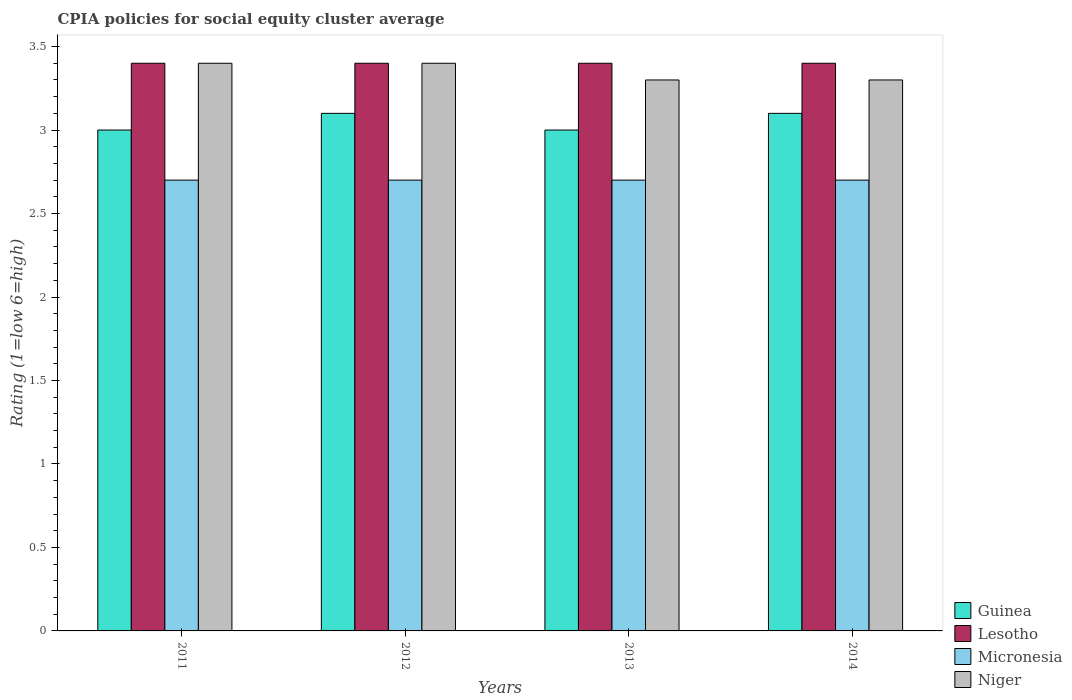How many different coloured bars are there?
Offer a terse response. 4. Are the number of bars per tick equal to the number of legend labels?
Make the answer very short. Yes. How many bars are there on the 1st tick from the left?
Offer a terse response. 4. What is the label of the 1st group of bars from the left?
Offer a very short reply. 2011. In how many cases, is the number of bars for a given year not equal to the number of legend labels?
Provide a succinct answer. 0. What is the CPIA rating in Guinea in 2011?
Offer a very short reply. 3. Across all years, what is the maximum CPIA rating in Guinea?
Your response must be concise. 3.1. Across all years, what is the minimum CPIA rating in Micronesia?
Your answer should be compact. 2.7. In which year was the CPIA rating in Micronesia maximum?
Make the answer very short. 2011. What is the total CPIA rating in Micronesia in the graph?
Your response must be concise. 10.8. What is the difference between the CPIA rating in Niger in 2011 and the CPIA rating in Micronesia in 2012?
Ensure brevity in your answer.  0.7. What is the average CPIA rating in Lesotho per year?
Give a very brief answer. 3.4. In the year 2012, what is the difference between the CPIA rating in Micronesia and CPIA rating in Niger?
Make the answer very short. -0.7. In how many years, is the CPIA rating in Micronesia greater than 2.3?
Provide a succinct answer. 4. What is the ratio of the CPIA rating in Micronesia in 2013 to that in 2014?
Make the answer very short. 1. Is the CPIA rating in Micronesia in 2011 less than that in 2012?
Offer a terse response. No. What is the difference between the highest and the second highest CPIA rating in Niger?
Offer a terse response. 0. What is the difference between the highest and the lowest CPIA rating in Guinea?
Offer a very short reply. 0.1. Is the sum of the CPIA rating in Guinea in 2012 and 2014 greater than the maximum CPIA rating in Micronesia across all years?
Make the answer very short. Yes. What does the 4th bar from the left in 2013 represents?
Provide a short and direct response. Niger. What does the 1st bar from the right in 2012 represents?
Offer a terse response. Niger. Is it the case that in every year, the sum of the CPIA rating in Micronesia and CPIA rating in Niger is greater than the CPIA rating in Guinea?
Make the answer very short. Yes. Are all the bars in the graph horizontal?
Provide a succinct answer. No. What is the difference between two consecutive major ticks on the Y-axis?
Provide a short and direct response. 0.5. Are the values on the major ticks of Y-axis written in scientific E-notation?
Ensure brevity in your answer.  No. Does the graph contain grids?
Your response must be concise. No. Where does the legend appear in the graph?
Give a very brief answer. Bottom right. How many legend labels are there?
Offer a terse response. 4. How are the legend labels stacked?
Ensure brevity in your answer.  Vertical. What is the title of the graph?
Make the answer very short. CPIA policies for social equity cluster average. What is the label or title of the Y-axis?
Your answer should be very brief. Rating (1=low 6=high). What is the Rating (1=low 6=high) of Guinea in 2011?
Offer a terse response. 3. What is the Rating (1=low 6=high) of Lesotho in 2011?
Make the answer very short. 3.4. What is the Rating (1=low 6=high) of Niger in 2011?
Your answer should be very brief. 3.4. What is the Rating (1=low 6=high) in Micronesia in 2012?
Keep it short and to the point. 2.7. What is the Rating (1=low 6=high) of Niger in 2012?
Offer a terse response. 3.4. What is the Rating (1=low 6=high) in Guinea in 2014?
Your answer should be compact. 3.1. What is the Rating (1=low 6=high) in Micronesia in 2014?
Provide a short and direct response. 2.7. What is the Rating (1=low 6=high) in Niger in 2014?
Offer a terse response. 3.3. Across all years, what is the maximum Rating (1=low 6=high) in Guinea?
Make the answer very short. 3.1. Across all years, what is the maximum Rating (1=low 6=high) in Micronesia?
Provide a succinct answer. 2.7. Across all years, what is the maximum Rating (1=low 6=high) in Niger?
Give a very brief answer. 3.4. Across all years, what is the minimum Rating (1=low 6=high) of Guinea?
Provide a succinct answer. 3. Across all years, what is the minimum Rating (1=low 6=high) in Lesotho?
Your answer should be compact. 3.4. Across all years, what is the minimum Rating (1=low 6=high) in Micronesia?
Give a very brief answer. 2.7. What is the total Rating (1=low 6=high) of Lesotho in the graph?
Your answer should be very brief. 13.6. What is the total Rating (1=low 6=high) in Micronesia in the graph?
Your answer should be very brief. 10.8. What is the total Rating (1=low 6=high) of Niger in the graph?
Your answer should be compact. 13.4. What is the difference between the Rating (1=low 6=high) of Guinea in 2011 and that in 2012?
Offer a terse response. -0.1. What is the difference between the Rating (1=low 6=high) of Lesotho in 2011 and that in 2012?
Your answer should be very brief. 0. What is the difference between the Rating (1=low 6=high) of Micronesia in 2011 and that in 2012?
Your answer should be very brief. 0. What is the difference between the Rating (1=low 6=high) in Niger in 2011 and that in 2012?
Your answer should be very brief. 0. What is the difference between the Rating (1=low 6=high) in Micronesia in 2011 and that in 2013?
Ensure brevity in your answer.  0. What is the difference between the Rating (1=low 6=high) of Niger in 2011 and that in 2013?
Offer a very short reply. 0.1. What is the difference between the Rating (1=low 6=high) in Guinea in 2011 and that in 2014?
Keep it short and to the point. -0.1. What is the difference between the Rating (1=low 6=high) in Lesotho in 2011 and that in 2014?
Your answer should be compact. 0. What is the difference between the Rating (1=low 6=high) in Micronesia in 2011 and that in 2014?
Provide a succinct answer. 0. What is the difference between the Rating (1=low 6=high) in Lesotho in 2012 and that in 2013?
Ensure brevity in your answer.  0. What is the difference between the Rating (1=low 6=high) in Micronesia in 2012 and that in 2013?
Make the answer very short. 0. What is the difference between the Rating (1=low 6=high) of Guinea in 2012 and that in 2014?
Ensure brevity in your answer.  0. What is the difference between the Rating (1=low 6=high) in Lesotho in 2012 and that in 2014?
Ensure brevity in your answer.  0. What is the difference between the Rating (1=low 6=high) of Niger in 2012 and that in 2014?
Offer a very short reply. 0.1. What is the difference between the Rating (1=low 6=high) in Micronesia in 2013 and that in 2014?
Make the answer very short. 0. What is the difference between the Rating (1=low 6=high) of Guinea in 2011 and the Rating (1=low 6=high) of Lesotho in 2012?
Give a very brief answer. -0.4. What is the difference between the Rating (1=low 6=high) in Guinea in 2011 and the Rating (1=low 6=high) in Micronesia in 2012?
Provide a succinct answer. 0.3. What is the difference between the Rating (1=low 6=high) in Guinea in 2011 and the Rating (1=low 6=high) in Micronesia in 2014?
Keep it short and to the point. 0.3. What is the difference between the Rating (1=low 6=high) in Lesotho in 2011 and the Rating (1=low 6=high) in Niger in 2014?
Offer a very short reply. 0.1. What is the difference between the Rating (1=low 6=high) in Guinea in 2012 and the Rating (1=low 6=high) in Niger in 2013?
Give a very brief answer. -0.2. What is the difference between the Rating (1=low 6=high) of Lesotho in 2012 and the Rating (1=low 6=high) of Micronesia in 2013?
Your answer should be compact. 0.7. What is the difference between the Rating (1=low 6=high) of Lesotho in 2012 and the Rating (1=low 6=high) of Niger in 2013?
Offer a very short reply. 0.1. What is the difference between the Rating (1=low 6=high) in Micronesia in 2012 and the Rating (1=low 6=high) in Niger in 2013?
Provide a short and direct response. -0.6. What is the difference between the Rating (1=low 6=high) of Guinea in 2012 and the Rating (1=low 6=high) of Lesotho in 2014?
Make the answer very short. -0.3. What is the difference between the Rating (1=low 6=high) in Guinea in 2012 and the Rating (1=low 6=high) in Micronesia in 2014?
Ensure brevity in your answer.  0.4. What is the difference between the Rating (1=low 6=high) of Lesotho in 2012 and the Rating (1=low 6=high) of Niger in 2014?
Provide a short and direct response. 0.1. What is the difference between the Rating (1=low 6=high) of Micronesia in 2012 and the Rating (1=low 6=high) of Niger in 2014?
Make the answer very short. -0.6. What is the difference between the Rating (1=low 6=high) of Guinea in 2013 and the Rating (1=low 6=high) of Niger in 2014?
Your response must be concise. -0.3. What is the average Rating (1=low 6=high) in Guinea per year?
Offer a very short reply. 3.05. What is the average Rating (1=low 6=high) of Micronesia per year?
Provide a succinct answer. 2.7. What is the average Rating (1=low 6=high) of Niger per year?
Your answer should be compact. 3.35. In the year 2011, what is the difference between the Rating (1=low 6=high) of Guinea and Rating (1=low 6=high) of Lesotho?
Give a very brief answer. -0.4. In the year 2011, what is the difference between the Rating (1=low 6=high) in Guinea and Rating (1=low 6=high) in Micronesia?
Your answer should be compact. 0.3. In the year 2011, what is the difference between the Rating (1=low 6=high) in Guinea and Rating (1=low 6=high) in Niger?
Provide a succinct answer. -0.4. In the year 2011, what is the difference between the Rating (1=low 6=high) in Lesotho and Rating (1=low 6=high) in Micronesia?
Make the answer very short. 0.7. In the year 2011, what is the difference between the Rating (1=low 6=high) in Micronesia and Rating (1=low 6=high) in Niger?
Your response must be concise. -0.7. In the year 2012, what is the difference between the Rating (1=low 6=high) in Guinea and Rating (1=low 6=high) in Lesotho?
Offer a terse response. -0.3. In the year 2012, what is the difference between the Rating (1=low 6=high) in Guinea and Rating (1=low 6=high) in Niger?
Keep it short and to the point. -0.3. In the year 2012, what is the difference between the Rating (1=low 6=high) of Lesotho and Rating (1=low 6=high) of Micronesia?
Offer a very short reply. 0.7. In the year 2012, what is the difference between the Rating (1=low 6=high) of Lesotho and Rating (1=low 6=high) of Niger?
Your response must be concise. 0. In the year 2012, what is the difference between the Rating (1=low 6=high) of Micronesia and Rating (1=low 6=high) of Niger?
Offer a very short reply. -0.7. In the year 2013, what is the difference between the Rating (1=low 6=high) in Guinea and Rating (1=low 6=high) in Lesotho?
Keep it short and to the point. -0.4. In the year 2013, what is the difference between the Rating (1=low 6=high) of Guinea and Rating (1=low 6=high) of Micronesia?
Ensure brevity in your answer.  0.3. In the year 2013, what is the difference between the Rating (1=low 6=high) of Lesotho and Rating (1=low 6=high) of Niger?
Your response must be concise. 0.1. In the year 2013, what is the difference between the Rating (1=low 6=high) in Micronesia and Rating (1=low 6=high) in Niger?
Provide a short and direct response. -0.6. In the year 2014, what is the difference between the Rating (1=low 6=high) in Guinea and Rating (1=low 6=high) in Micronesia?
Offer a terse response. 0.4. In the year 2014, what is the difference between the Rating (1=low 6=high) of Lesotho and Rating (1=low 6=high) of Micronesia?
Make the answer very short. 0.7. In the year 2014, what is the difference between the Rating (1=low 6=high) of Lesotho and Rating (1=low 6=high) of Niger?
Give a very brief answer. 0.1. What is the ratio of the Rating (1=low 6=high) of Guinea in 2011 to that in 2012?
Keep it short and to the point. 0.97. What is the ratio of the Rating (1=low 6=high) of Micronesia in 2011 to that in 2012?
Offer a very short reply. 1. What is the ratio of the Rating (1=low 6=high) in Guinea in 2011 to that in 2013?
Offer a terse response. 1. What is the ratio of the Rating (1=low 6=high) of Lesotho in 2011 to that in 2013?
Give a very brief answer. 1. What is the ratio of the Rating (1=low 6=high) in Niger in 2011 to that in 2013?
Offer a terse response. 1.03. What is the ratio of the Rating (1=low 6=high) of Micronesia in 2011 to that in 2014?
Your answer should be compact. 1. What is the ratio of the Rating (1=low 6=high) in Niger in 2011 to that in 2014?
Your response must be concise. 1.03. What is the ratio of the Rating (1=low 6=high) in Guinea in 2012 to that in 2013?
Your answer should be compact. 1.03. What is the ratio of the Rating (1=low 6=high) of Lesotho in 2012 to that in 2013?
Your answer should be compact. 1. What is the ratio of the Rating (1=low 6=high) of Niger in 2012 to that in 2013?
Keep it short and to the point. 1.03. What is the ratio of the Rating (1=low 6=high) in Micronesia in 2012 to that in 2014?
Offer a very short reply. 1. What is the ratio of the Rating (1=low 6=high) in Niger in 2012 to that in 2014?
Offer a very short reply. 1.03. What is the ratio of the Rating (1=low 6=high) of Guinea in 2013 to that in 2014?
Offer a terse response. 0.97. What is the ratio of the Rating (1=low 6=high) of Lesotho in 2013 to that in 2014?
Keep it short and to the point. 1. What is the ratio of the Rating (1=low 6=high) in Micronesia in 2013 to that in 2014?
Your answer should be very brief. 1. What is the difference between the highest and the second highest Rating (1=low 6=high) in Micronesia?
Offer a terse response. 0. What is the difference between the highest and the lowest Rating (1=low 6=high) in Micronesia?
Provide a short and direct response. 0. What is the difference between the highest and the lowest Rating (1=low 6=high) in Niger?
Offer a terse response. 0.1. 